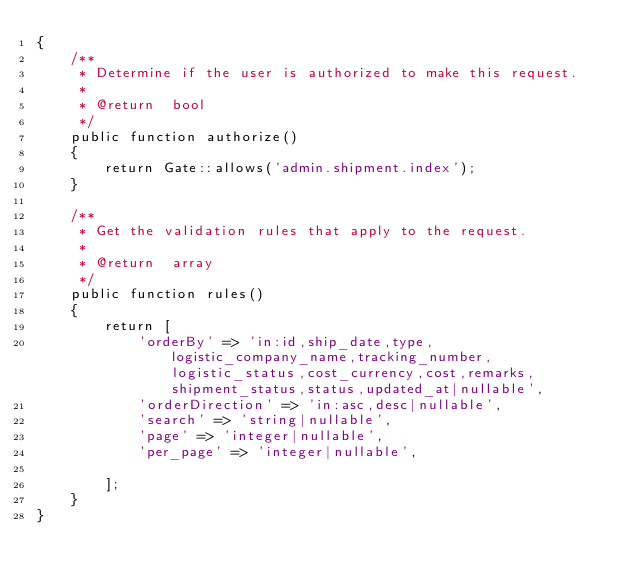<code> <loc_0><loc_0><loc_500><loc_500><_PHP_>{
    /**
     * Determine if the user is authorized to make this request.
     *
     * @return  bool
     */
    public function authorize()
    {
        return Gate::allows('admin.shipment.index');
    }

    /**
     * Get the validation rules that apply to the request.
     *
     * @return  array
     */
    public function rules()
    {
        return [
            'orderBy' => 'in:id,ship_date,type,logistic_company_name,tracking_number,logistic_status,cost_currency,cost,remarks,shipment_status,status,updated_at|nullable',
            'orderDirection' => 'in:asc,desc|nullable',
            'search' => 'string|nullable',
            'page' => 'integer|nullable',
            'per_page' => 'integer|nullable',

        ];
    }
}
</code> 